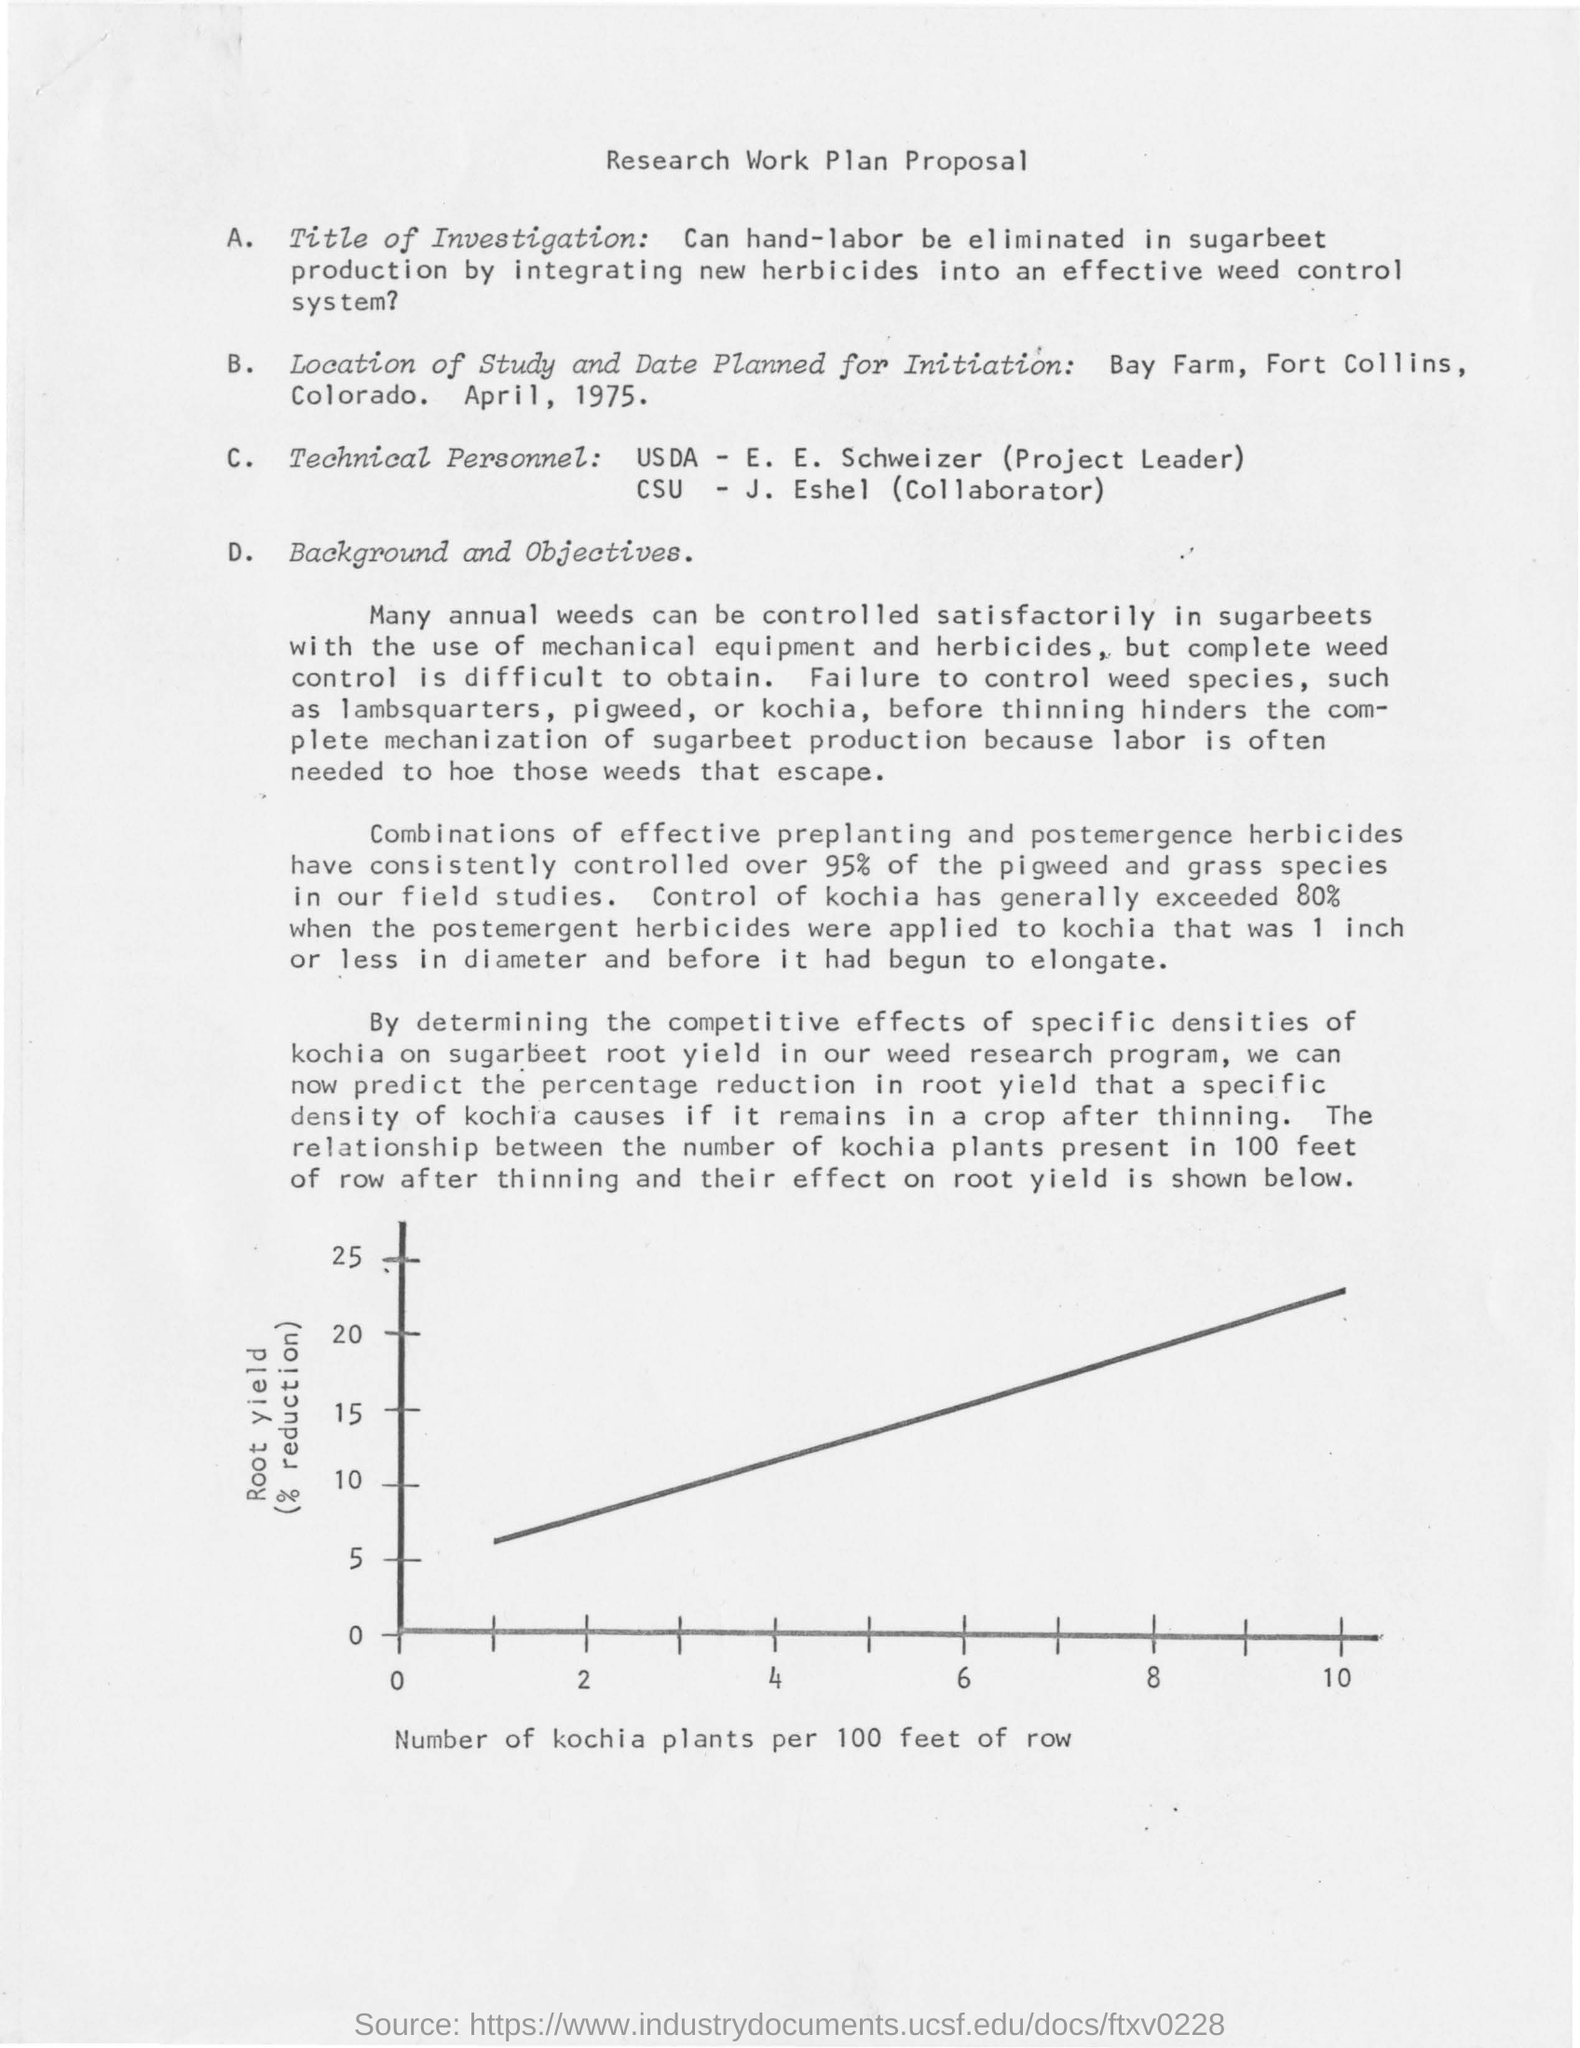Where is the location of study conducted ?
Provide a succinct answer. Bay Farm, Fort Collins, Colorado. What is shown on the x-axis of the graph?
Ensure brevity in your answer.  Number of Kochia plants per 100 feet of row. 